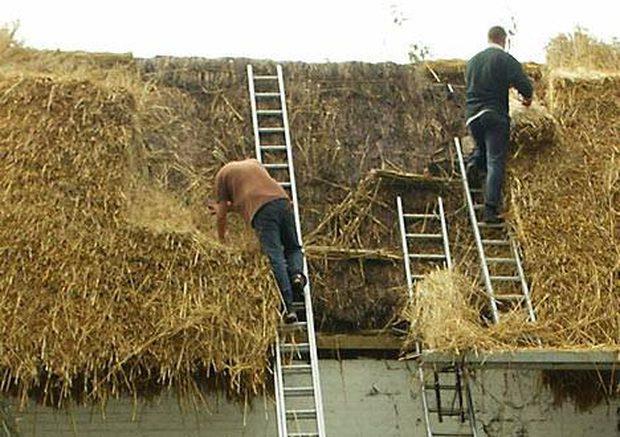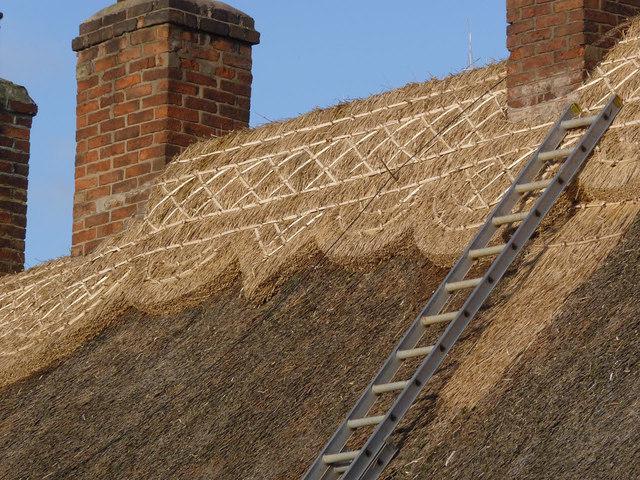The first image is the image on the left, the second image is the image on the right. Given the left and right images, does the statement "Men are repairing a roof." hold true? Answer yes or no. Yes. The first image is the image on the left, the second image is the image on the right. Evaluate the accuracy of this statement regarding the images: "At least one man is standing on a ladder propped against an unfinished thatched roof.". Is it true? Answer yes or no. Yes. 